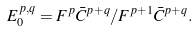<formula> <loc_0><loc_0><loc_500><loc_500>E _ { 0 } ^ { p , q } = F ^ { p } \bar { C } ^ { p + q } / F ^ { p + 1 } \bar { C } ^ { p + q } .</formula> 